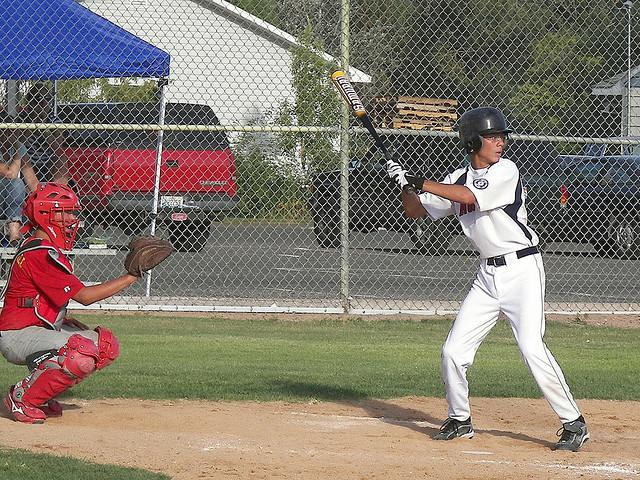Why is he holding the bat behind him?

Choices:
A) intimidate others
B) lost bet
C) novice
D) hit ball hit ball 